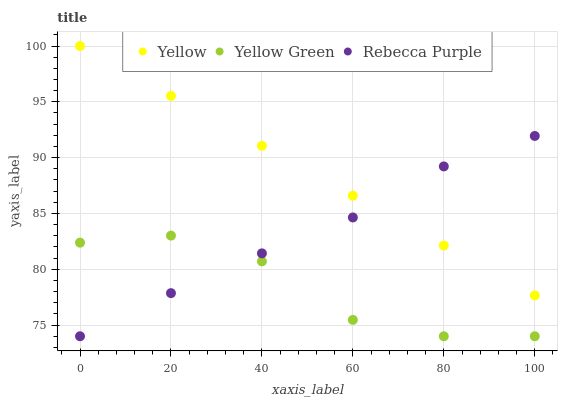Does Yellow Green have the minimum area under the curve?
Answer yes or no. Yes. Does Yellow have the maximum area under the curve?
Answer yes or no. Yes. Does Rebecca Purple have the minimum area under the curve?
Answer yes or no. No. Does Rebecca Purple have the maximum area under the curve?
Answer yes or no. No. Is Yellow the smoothest?
Answer yes or no. Yes. Is Yellow Green the roughest?
Answer yes or no. Yes. Is Rebecca Purple the smoothest?
Answer yes or no. No. Is Rebecca Purple the roughest?
Answer yes or no. No. Does Yellow Green have the lowest value?
Answer yes or no. Yes. Does Yellow have the lowest value?
Answer yes or no. No. Does Yellow have the highest value?
Answer yes or no. Yes. Does Rebecca Purple have the highest value?
Answer yes or no. No. Is Yellow Green less than Yellow?
Answer yes or no. Yes. Is Yellow greater than Yellow Green?
Answer yes or no. Yes. Does Yellow Green intersect Rebecca Purple?
Answer yes or no. Yes. Is Yellow Green less than Rebecca Purple?
Answer yes or no. No. Is Yellow Green greater than Rebecca Purple?
Answer yes or no. No. Does Yellow Green intersect Yellow?
Answer yes or no. No. 